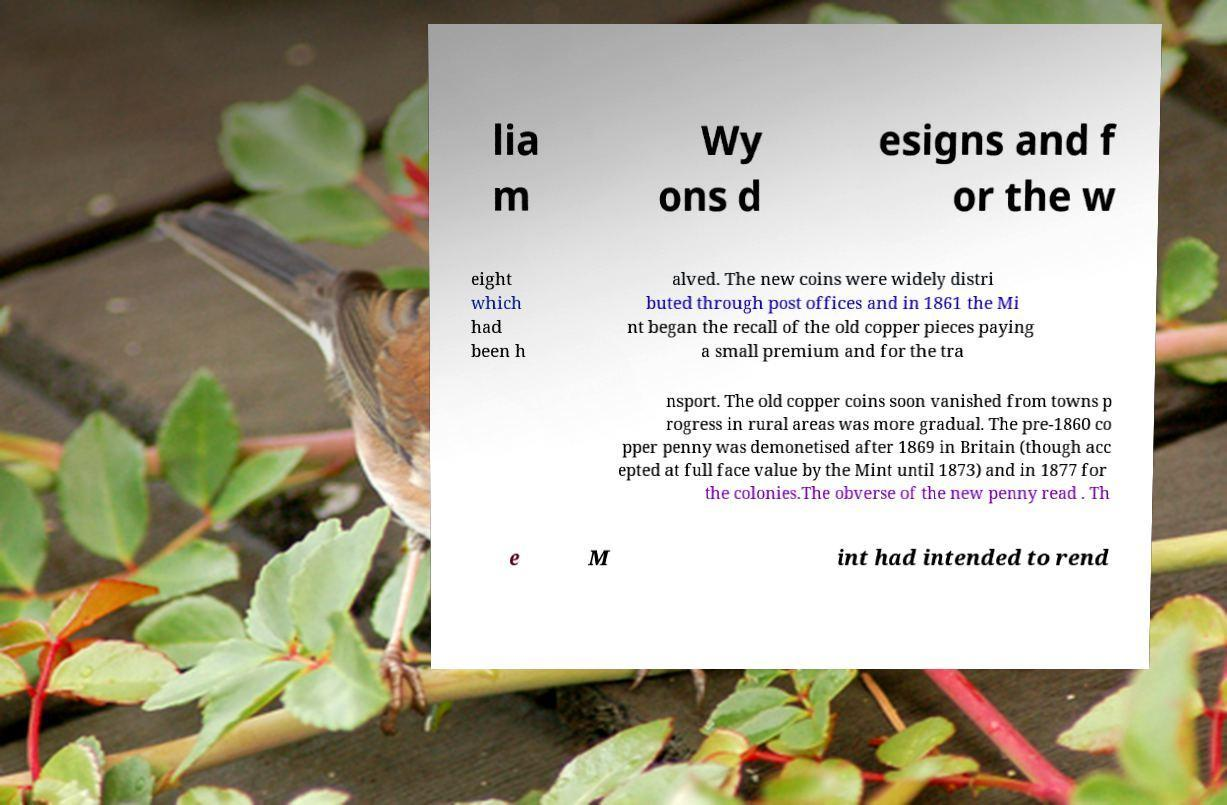Please identify and transcribe the text found in this image. lia m Wy ons d esigns and f or the w eight which had been h alved. The new coins were widely distri buted through post offices and in 1861 the Mi nt began the recall of the old copper pieces paying a small premium and for the tra nsport. The old copper coins soon vanished from towns p rogress in rural areas was more gradual. The pre-1860 co pper penny was demonetised after 1869 in Britain (though acc epted at full face value by the Mint until 1873) and in 1877 for the colonies.The obverse of the new penny read . Th e M int had intended to rend 